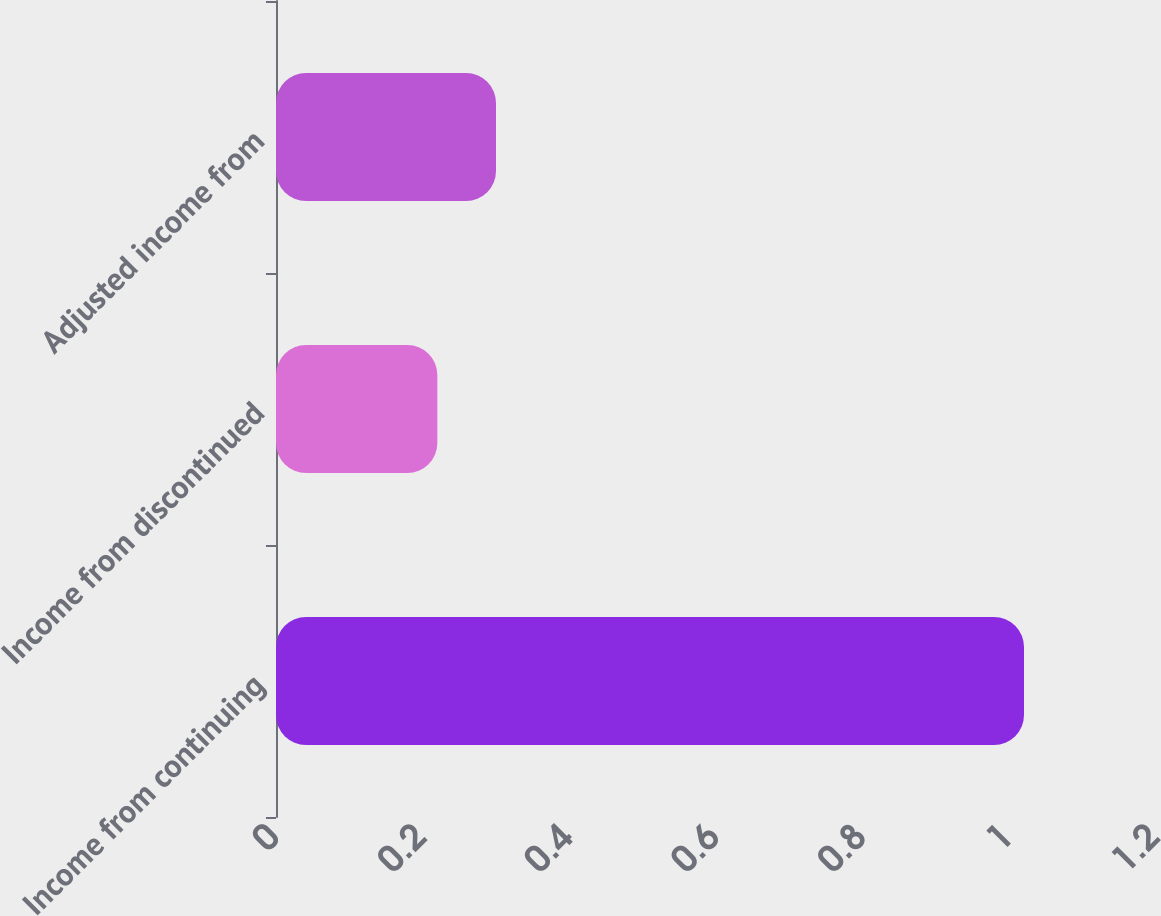Convert chart. <chart><loc_0><loc_0><loc_500><loc_500><bar_chart><fcel>Income from continuing<fcel>Income from discontinued<fcel>Adjusted income from<nl><fcel>1.02<fcel>0.22<fcel>0.3<nl></chart> 